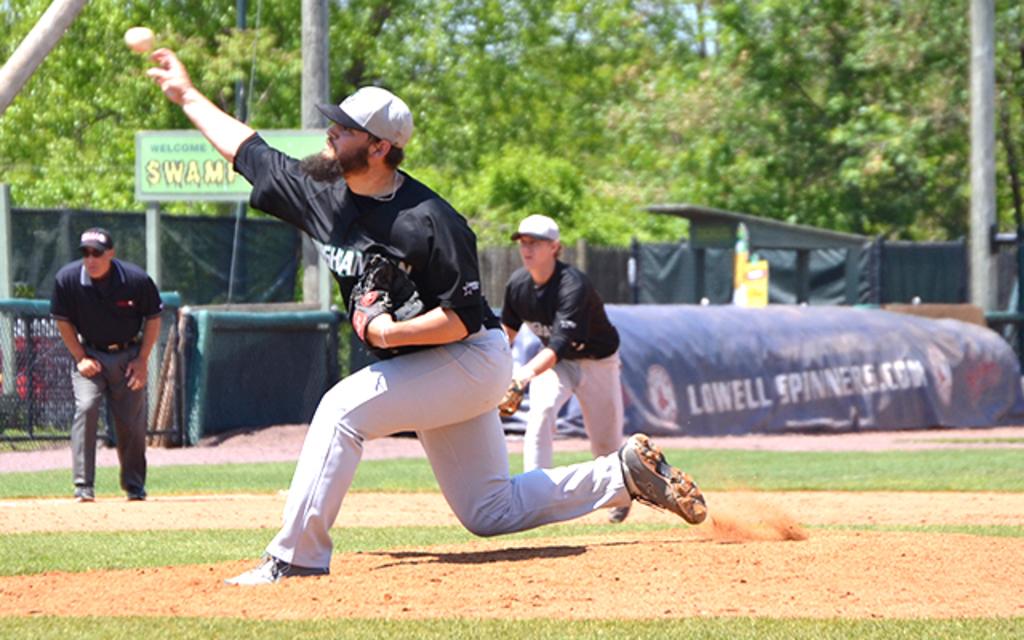What website is on the boards?
Give a very brief answer. Lowellspinners.com. What is on the green sign?
Your response must be concise. Swamp. 